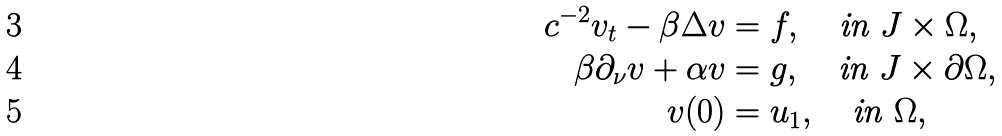Convert formula to latex. <formula><loc_0><loc_0><loc_500><loc_500>c ^ { - 2 } v _ { t } - \beta \Delta v & = f , \quad \text {in } J \times \Omega , \\ \beta \partial _ { \nu } v + \alpha v & = g , \quad \text {in } J \times \partial \Omega , \\ v ( 0 ) & = u _ { 1 } , \quad \text {in } \Omega ,</formula> 